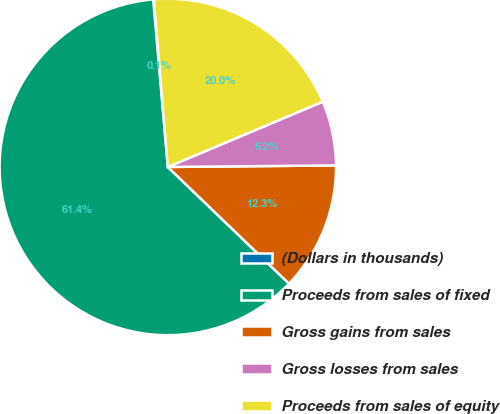Convert chart. <chart><loc_0><loc_0><loc_500><loc_500><pie_chart><fcel>(Dollars in thousands)<fcel>Proceeds from sales of fixed<fcel>Gross gains from sales<fcel>Gross losses from sales<fcel>Proceeds from sales of equity<nl><fcel>0.07%<fcel>61.42%<fcel>12.34%<fcel>6.2%<fcel>19.97%<nl></chart> 